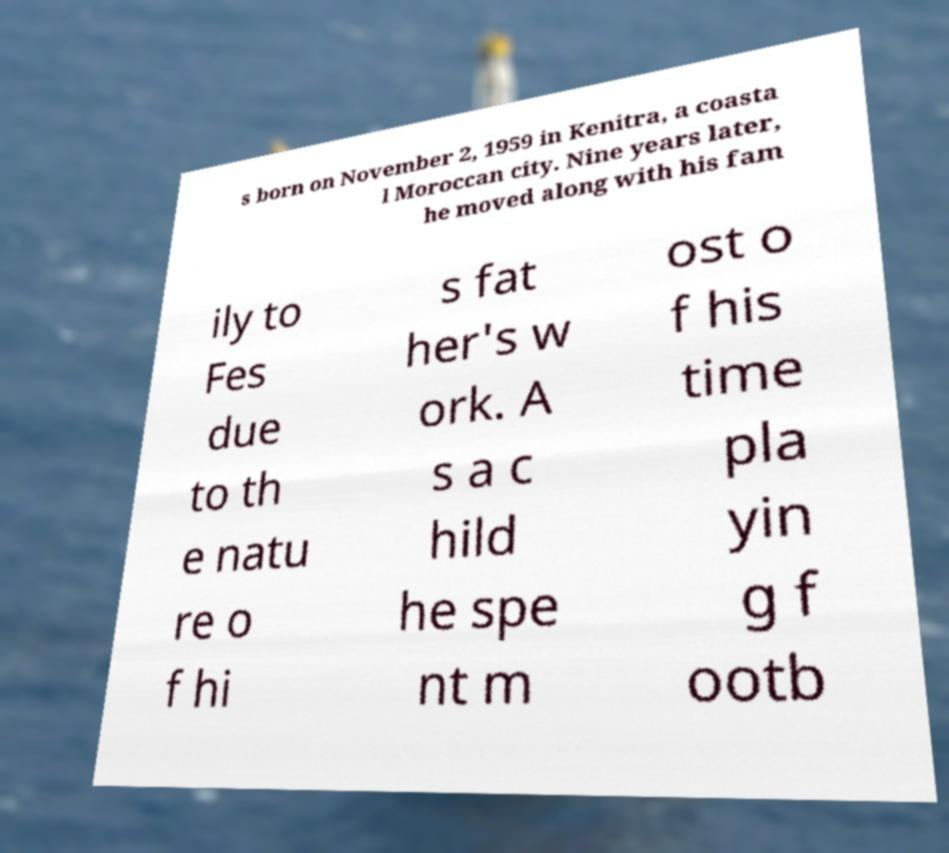I need the written content from this picture converted into text. Can you do that? s born on November 2, 1959 in Kenitra, a coasta l Moroccan city. Nine years later, he moved along with his fam ily to Fes due to th e natu re o f hi s fat her's w ork. A s a c hild he spe nt m ost o f his time pla yin g f ootb 